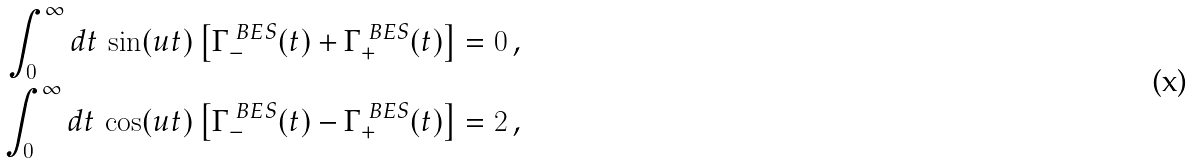Convert formula to latex. <formula><loc_0><loc_0><loc_500><loc_500>\int _ { 0 } ^ { \infty } d t \, \sin ( u t ) \left [ \Gamma ^ { \ B E S } _ { - } ( t ) + \Gamma ^ { \ B E S } _ { + } ( t ) \right ] & = 0 \, , \\ \int _ { 0 } ^ { \infty } d t \, \cos ( u t ) \left [ \Gamma ^ { \ B E S } _ { - } ( t ) - \Gamma ^ { \ B E S } _ { + } ( t ) \right ] & = 2 \, ,</formula> 